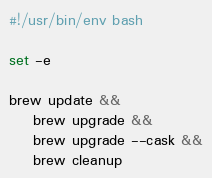Convert code to text. <code><loc_0><loc_0><loc_500><loc_500><_Bash_>#!/usr/bin/env bash

set -e

brew update &&
    brew upgrade &&
    brew upgrade --cask &&
    brew cleanup
</code> 